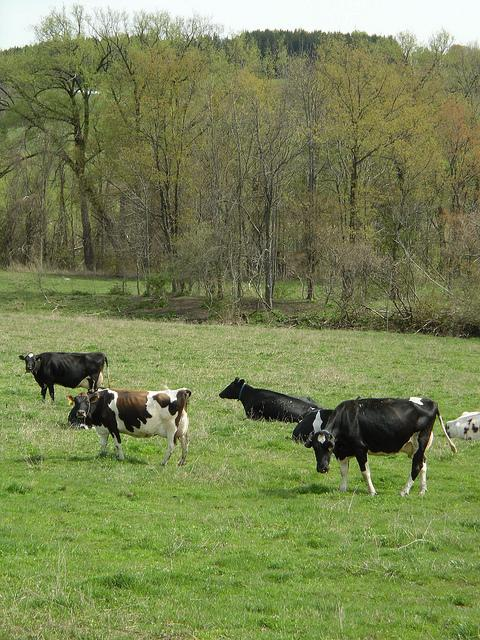What color is the strange cow just ahead to the left?

Choices:
A) brown
B) white
C) black
D) gray brown 